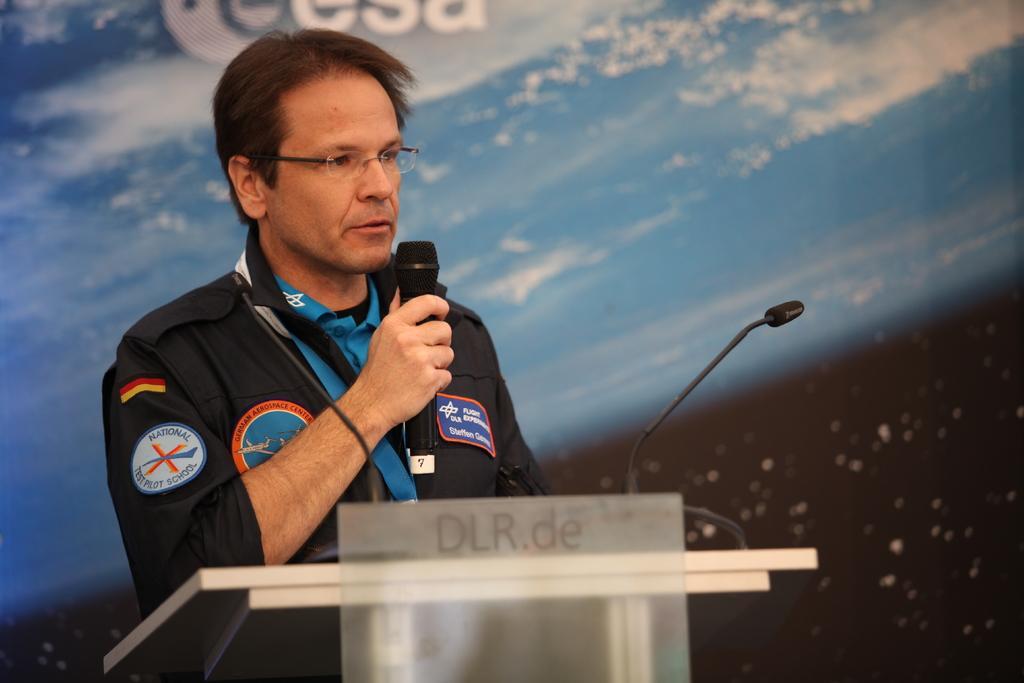Can you describe this image briefly? In this image we can see a person standing beside a speaker stand holding a mic. We can also see a mic with a stand. On the backside we can see some text on a banner. 